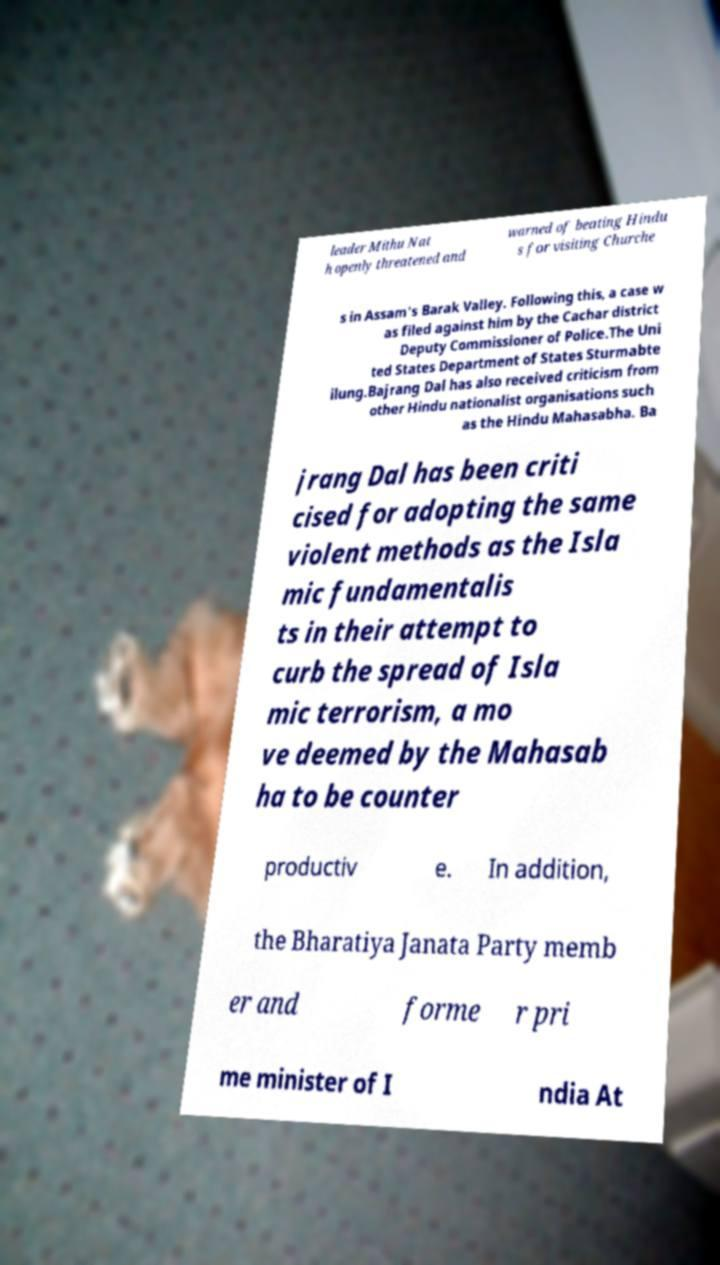Could you assist in decoding the text presented in this image and type it out clearly? leader Mithu Nat h openly threatened and warned of beating Hindu s for visiting Churche s in Assam's Barak Valley. Following this, a case w as filed against him by the Cachar district Deputy Commissioner of Police.The Uni ted States Department of States Sturmabte ilung.Bajrang Dal has also received criticism from other Hindu nationalist organisations such as the Hindu Mahasabha. Ba jrang Dal has been criti cised for adopting the same violent methods as the Isla mic fundamentalis ts in their attempt to curb the spread of Isla mic terrorism, a mo ve deemed by the Mahasab ha to be counter productiv e. In addition, the Bharatiya Janata Party memb er and forme r pri me minister of I ndia At 